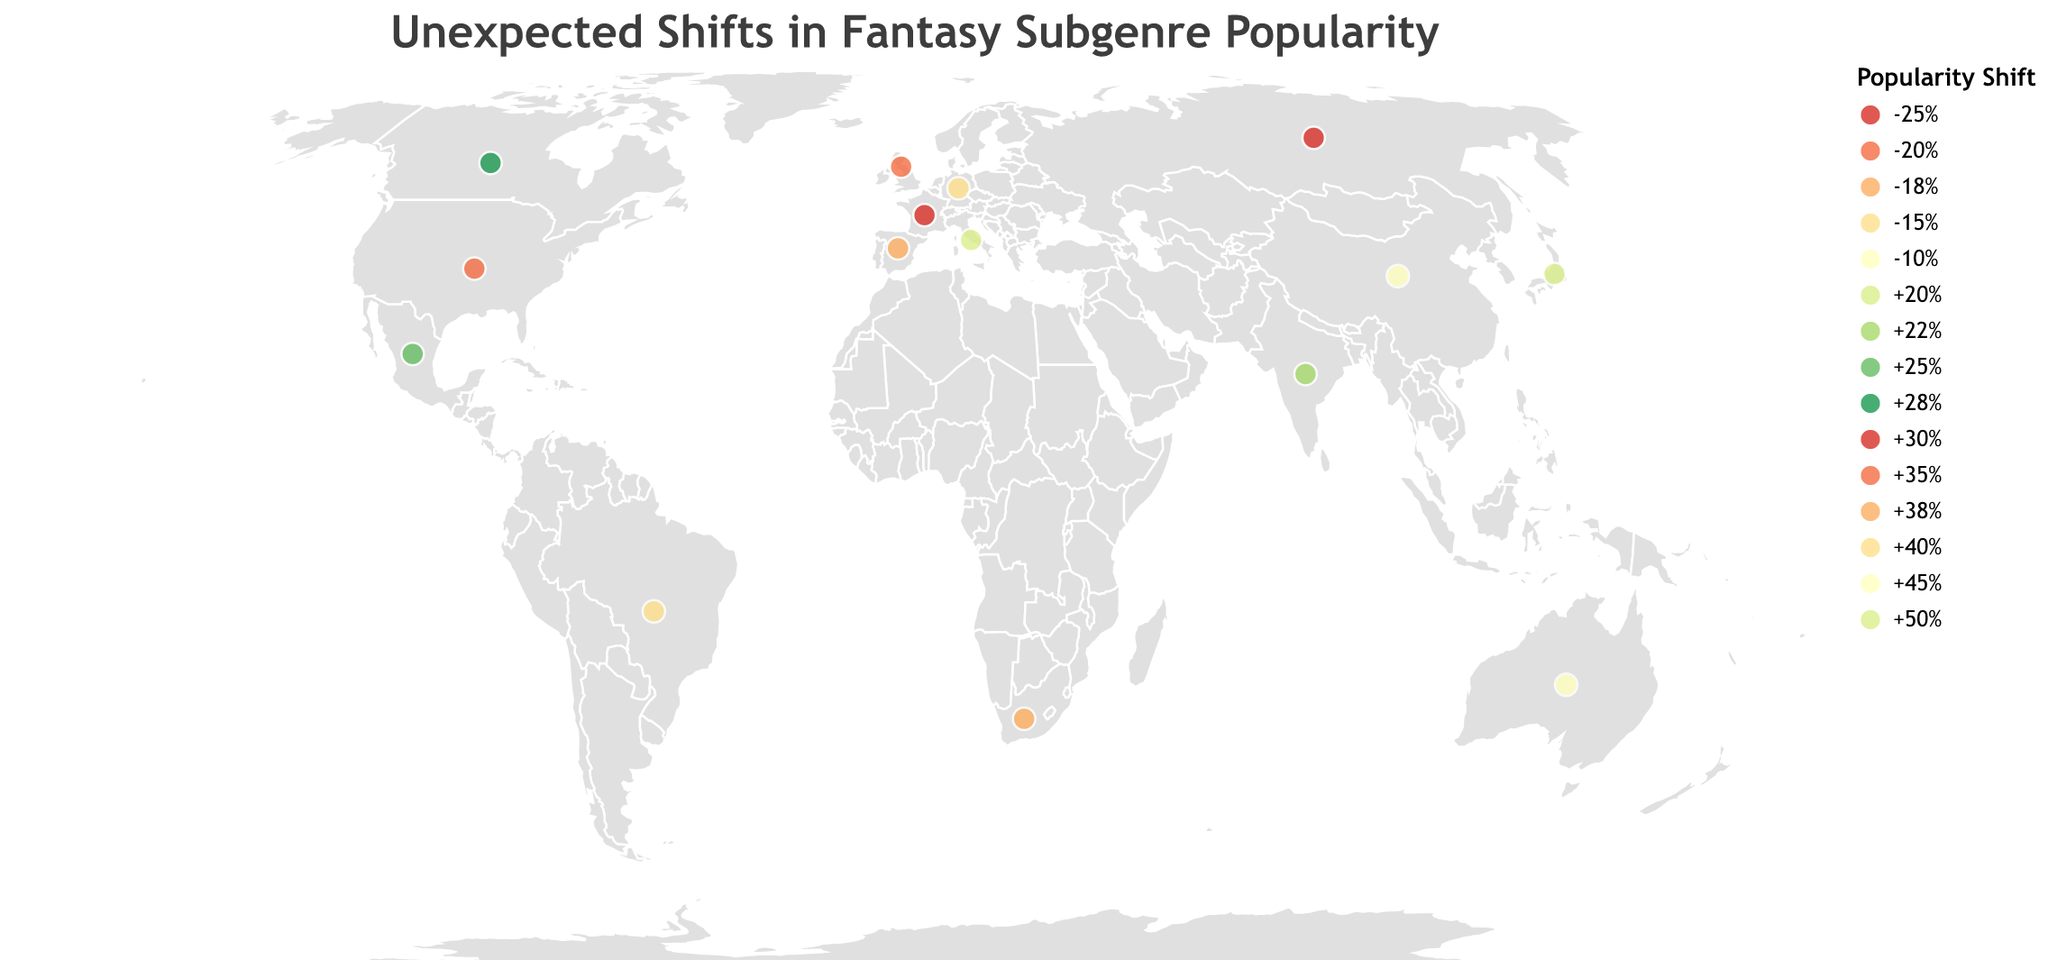What is the title of the plot? The title of the plot is always placed at the top, usually in a larger font size compared to other texts. Here, the title is, "Unexpected Shifts in Fantasy Subgenre Popularity."
Answer: Unexpected Shifts in Fantasy Subgenre Popularity Which country had the highest positive shift in subgenre popularity and what was the subgenre? By examining the popularity shifts and corresponding subgenres for each country, the highest positive shift is "+50%," occurring in Japan with the subgenre "Isekai."
Answer: Japan, Isekai How many countries experienced a negative shift in subgenre popularity? By detaching the countries with negative shifts, these are United Kingdom (-20%), Germany (-15%), France (-25%), Spain (-18%), and China (-10%). This sums up to five countries.
Answer: 5 Which subgenre saw a popularity increase in both Australia and South Africa, and what were the sizes of these increases? By matching subgenres and positive shifts, both Australia and South Africa saw increases for "New Weird" (+45%) and "Solarpunk" (+38%), respectively.
Answer: New Weird (+45%), Solarpunk (+38%) What is the combined popularity shift of Grimdark in the United States and Arthurian Fantasy in France? The popularity shifts are "+35%" for Grimdark in the United States and "-25%" for Arthurian Fantasy in France. Combining these means simply adding the percentages: +35% + (-25%) = +10%.
Answer: +10% Which country experienced an unexpected decline in Magical Realism's popularity, and by what percentage? By looking for the subgenre "Magical Realism," Germany experienced a decline of "-15%."
Answer: Germany, -15% What is the average positive shift in popularity for all countries listed? Adding all positive shifts: +20% +22% +25% +28% +30% +35% +38% +40% +45% +50% = 333%. Total positive shifts: 10. Thus, 333%/10 = 33.3%.
Answer: 33.3% Which country and subgenre combination saw the least decline in popularity, and what was the percentage? Finding the smallest negative shift, which is "-10%," provides us with China and the subgenre "Wuxia."
Answer: China, Wuxia, -10% What was the total popularity shift percentage for countries in the Americas (Mexico, United States, Brazil, Canada) individually, and what’s the cumulative result? Mexico: +25%, US: +35%, Brazil: +40%, and Canada: +28%. Adding them gives us +25% + 35% + 40% + 28% = +128%.
Answer: +128% What subgenre became more popular in Brazil in 2020 and by how much? By locating Brazil in 2020 data, Afrofuturism's popularity increased by "+40%" in Brazil.
Answer: Afrofuturism, +40% 